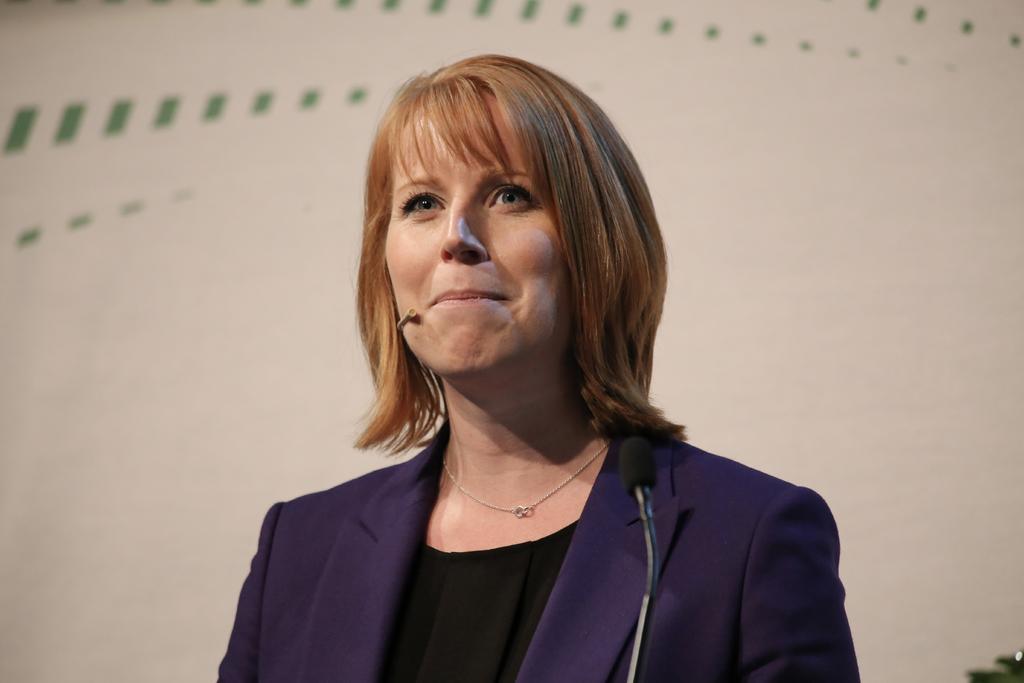Can you describe this image briefly? In this image I can see a woman wearing black colored dress and purple colored blazer and I can see a microphone in front of her. I can see the cream and green colored background. 